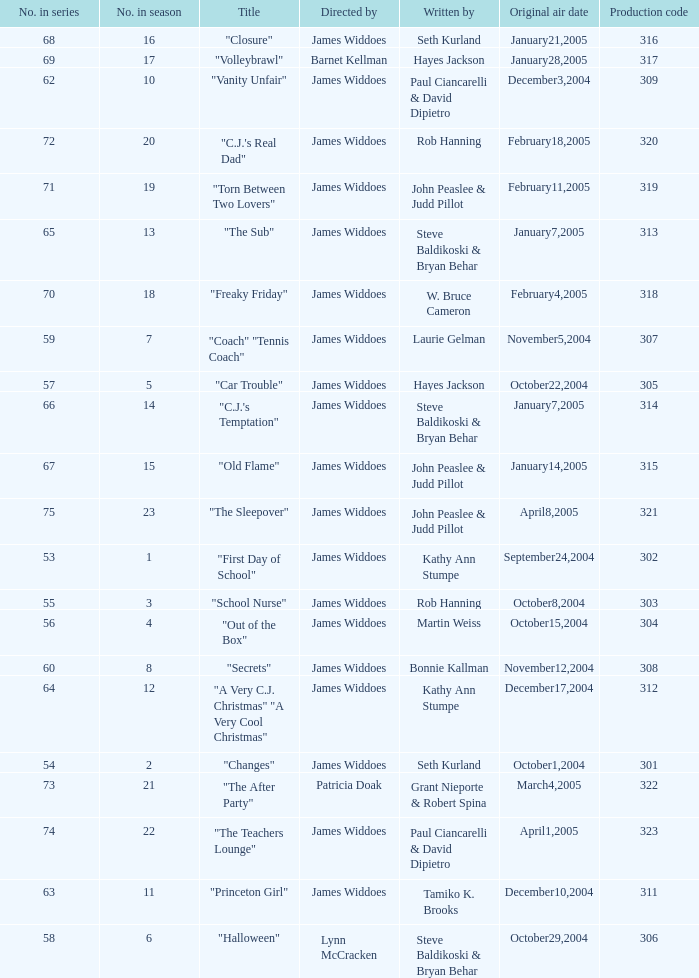What date was the episode originally aired that was directed by James Widdoes and the production code is 320? February18,2005. 